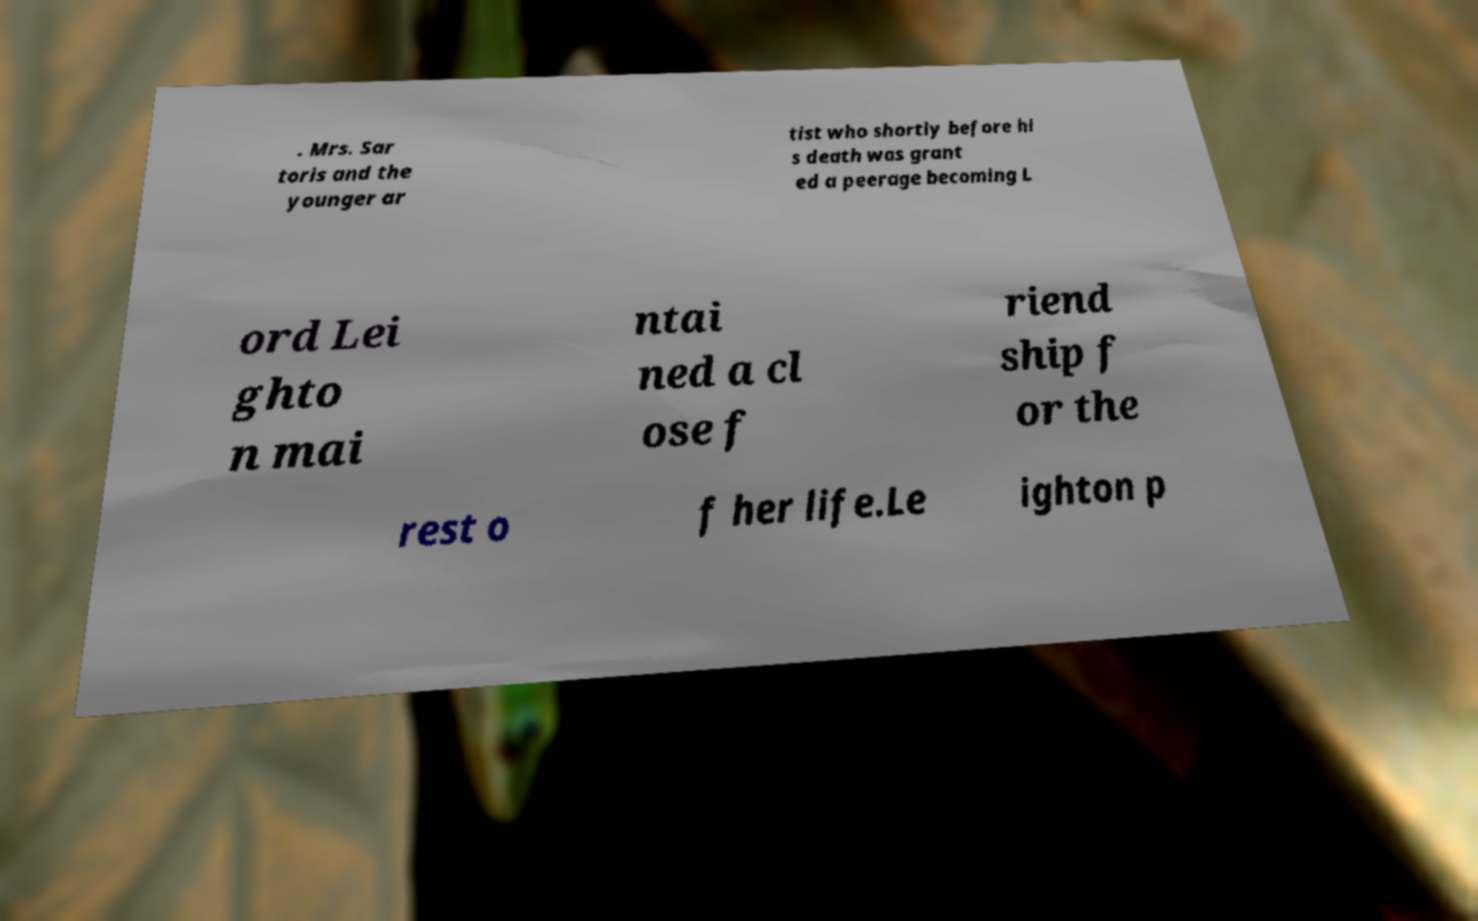Please identify and transcribe the text found in this image. . Mrs. Sar toris and the younger ar tist who shortly before hi s death was grant ed a peerage becoming L ord Lei ghto n mai ntai ned a cl ose f riend ship f or the rest o f her life.Le ighton p 